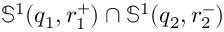<formula> <loc_0><loc_0><loc_500><loc_500>\mathbb { S } ^ { 1 } ( q _ { 1 } , r _ { 1 } ^ { + } ) \cap \mathbb { S } ^ { 1 } ( q _ { 2 } , r _ { 2 } ^ { - } )</formula> 